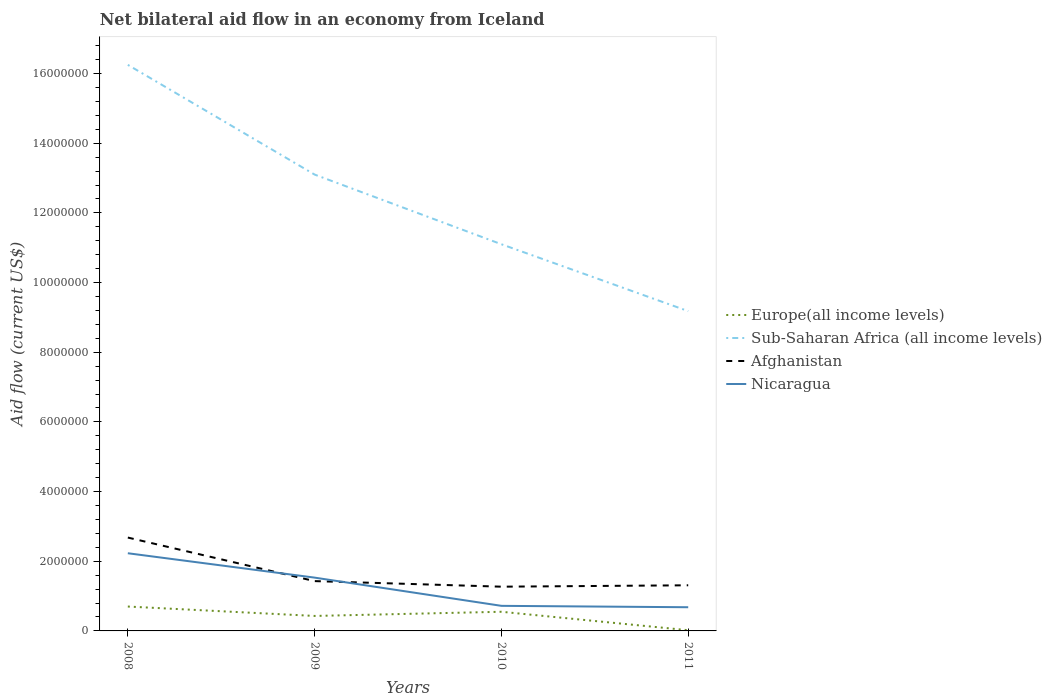Across all years, what is the maximum net bilateral aid flow in Afghanistan?
Your answer should be compact. 1.27e+06. What is the total net bilateral aid flow in Sub-Saharan Africa (all income levels) in the graph?
Provide a short and direct response. 7.07e+06. What is the difference between the highest and the second highest net bilateral aid flow in Afghanistan?
Your response must be concise. 1.41e+06. Are the values on the major ticks of Y-axis written in scientific E-notation?
Offer a terse response. No. Does the graph contain any zero values?
Ensure brevity in your answer.  No. Where does the legend appear in the graph?
Make the answer very short. Center right. How many legend labels are there?
Your answer should be compact. 4. What is the title of the graph?
Offer a terse response. Net bilateral aid flow in an economy from Iceland. What is the Aid flow (current US$) of Sub-Saharan Africa (all income levels) in 2008?
Make the answer very short. 1.62e+07. What is the Aid flow (current US$) in Afghanistan in 2008?
Your answer should be compact. 2.68e+06. What is the Aid flow (current US$) of Nicaragua in 2008?
Provide a succinct answer. 2.23e+06. What is the Aid flow (current US$) in Sub-Saharan Africa (all income levels) in 2009?
Provide a short and direct response. 1.31e+07. What is the Aid flow (current US$) of Afghanistan in 2009?
Your answer should be compact. 1.43e+06. What is the Aid flow (current US$) in Nicaragua in 2009?
Keep it short and to the point. 1.53e+06. What is the Aid flow (current US$) in Sub-Saharan Africa (all income levels) in 2010?
Your response must be concise. 1.11e+07. What is the Aid flow (current US$) in Afghanistan in 2010?
Offer a terse response. 1.27e+06. What is the Aid flow (current US$) of Nicaragua in 2010?
Your answer should be very brief. 7.20e+05. What is the Aid flow (current US$) in Europe(all income levels) in 2011?
Offer a very short reply. 2.00e+04. What is the Aid flow (current US$) in Sub-Saharan Africa (all income levels) in 2011?
Offer a terse response. 9.18e+06. What is the Aid flow (current US$) in Afghanistan in 2011?
Offer a terse response. 1.31e+06. What is the Aid flow (current US$) of Nicaragua in 2011?
Provide a short and direct response. 6.80e+05. Across all years, what is the maximum Aid flow (current US$) in Sub-Saharan Africa (all income levels)?
Give a very brief answer. 1.62e+07. Across all years, what is the maximum Aid flow (current US$) of Afghanistan?
Offer a terse response. 2.68e+06. Across all years, what is the maximum Aid flow (current US$) of Nicaragua?
Your answer should be very brief. 2.23e+06. Across all years, what is the minimum Aid flow (current US$) of Sub-Saharan Africa (all income levels)?
Ensure brevity in your answer.  9.18e+06. Across all years, what is the minimum Aid flow (current US$) of Afghanistan?
Keep it short and to the point. 1.27e+06. Across all years, what is the minimum Aid flow (current US$) of Nicaragua?
Make the answer very short. 6.80e+05. What is the total Aid flow (current US$) of Europe(all income levels) in the graph?
Give a very brief answer. 1.70e+06. What is the total Aid flow (current US$) of Sub-Saharan Africa (all income levels) in the graph?
Keep it short and to the point. 4.96e+07. What is the total Aid flow (current US$) in Afghanistan in the graph?
Your answer should be compact. 6.69e+06. What is the total Aid flow (current US$) in Nicaragua in the graph?
Offer a terse response. 5.16e+06. What is the difference between the Aid flow (current US$) of Europe(all income levels) in 2008 and that in 2009?
Make the answer very short. 2.70e+05. What is the difference between the Aid flow (current US$) in Sub-Saharan Africa (all income levels) in 2008 and that in 2009?
Offer a very short reply. 3.15e+06. What is the difference between the Aid flow (current US$) of Afghanistan in 2008 and that in 2009?
Your response must be concise. 1.25e+06. What is the difference between the Aid flow (current US$) in Nicaragua in 2008 and that in 2009?
Make the answer very short. 7.00e+05. What is the difference between the Aid flow (current US$) in Europe(all income levels) in 2008 and that in 2010?
Give a very brief answer. 1.50e+05. What is the difference between the Aid flow (current US$) of Sub-Saharan Africa (all income levels) in 2008 and that in 2010?
Give a very brief answer. 5.15e+06. What is the difference between the Aid flow (current US$) of Afghanistan in 2008 and that in 2010?
Your answer should be very brief. 1.41e+06. What is the difference between the Aid flow (current US$) in Nicaragua in 2008 and that in 2010?
Your answer should be compact. 1.51e+06. What is the difference between the Aid flow (current US$) of Europe(all income levels) in 2008 and that in 2011?
Your response must be concise. 6.80e+05. What is the difference between the Aid flow (current US$) of Sub-Saharan Africa (all income levels) in 2008 and that in 2011?
Provide a short and direct response. 7.07e+06. What is the difference between the Aid flow (current US$) in Afghanistan in 2008 and that in 2011?
Give a very brief answer. 1.37e+06. What is the difference between the Aid flow (current US$) of Nicaragua in 2008 and that in 2011?
Your answer should be very brief. 1.55e+06. What is the difference between the Aid flow (current US$) of Sub-Saharan Africa (all income levels) in 2009 and that in 2010?
Provide a succinct answer. 2.00e+06. What is the difference between the Aid flow (current US$) in Afghanistan in 2009 and that in 2010?
Your answer should be compact. 1.60e+05. What is the difference between the Aid flow (current US$) in Nicaragua in 2009 and that in 2010?
Your answer should be compact. 8.10e+05. What is the difference between the Aid flow (current US$) in Europe(all income levels) in 2009 and that in 2011?
Keep it short and to the point. 4.10e+05. What is the difference between the Aid flow (current US$) in Sub-Saharan Africa (all income levels) in 2009 and that in 2011?
Your answer should be very brief. 3.92e+06. What is the difference between the Aid flow (current US$) of Nicaragua in 2009 and that in 2011?
Your response must be concise. 8.50e+05. What is the difference between the Aid flow (current US$) of Europe(all income levels) in 2010 and that in 2011?
Make the answer very short. 5.30e+05. What is the difference between the Aid flow (current US$) in Sub-Saharan Africa (all income levels) in 2010 and that in 2011?
Provide a short and direct response. 1.92e+06. What is the difference between the Aid flow (current US$) in Afghanistan in 2010 and that in 2011?
Provide a short and direct response. -4.00e+04. What is the difference between the Aid flow (current US$) of Nicaragua in 2010 and that in 2011?
Keep it short and to the point. 4.00e+04. What is the difference between the Aid flow (current US$) of Europe(all income levels) in 2008 and the Aid flow (current US$) of Sub-Saharan Africa (all income levels) in 2009?
Keep it short and to the point. -1.24e+07. What is the difference between the Aid flow (current US$) in Europe(all income levels) in 2008 and the Aid flow (current US$) in Afghanistan in 2009?
Provide a succinct answer. -7.30e+05. What is the difference between the Aid flow (current US$) of Europe(all income levels) in 2008 and the Aid flow (current US$) of Nicaragua in 2009?
Offer a very short reply. -8.30e+05. What is the difference between the Aid flow (current US$) in Sub-Saharan Africa (all income levels) in 2008 and the Aid flow (current US$) in Afghanistan in 2009?
Ensure brevity in your answer.  1.48e+07. What is the difference between the Aid flow (current US$) in Sub-Saharan Africa (all income levels) in 2008 and the Aid flow (current US$) in Nicaragua in 2009?
Keep it short and to the point. 1.47e+07. What is the difference between the Aid flow (current US$) of Afghanistan in 2008 and the Aid flow (current US$) of Nicaragua in 2009?
Provide a succinct answer. 1.15e+06. What is the difference between the Aid flow (current US$) of Europe(all income levels) in 2008 and the Aid flow (current US$) of Sub-Saharan Africa (all income levels) in 2010?
Ensure brevity in your answer.  -1.04e+07. What is the difference between the Aid flow (current US$) of Europe(all income levels) in 2008 and the Aid flow (current US$) of Afghanistan in 2010?
Your response must be concise. -5.70e+05. What is the difference between the Aid flow (current US$) of Sub-Saharan Africa (all income levels) in 2008 and the Aid flow (current US$) of Afghanistan in 2010?
Offer a very short reply. 1.50e+07. What is the difference between the Aid flow (current US$) of Sub-Saharan Africa (all income levels) in 2008 and the Aid flow (current US$) of Nicaragua in 2010?
Your answer should be compact. 1.55e+07. What is the difference between the Aid flow (current US$) of Afghanistan in 2008 and the Aid flow (current US$) of Nicaragua in 2010?
Offer a terse response. 1.96e+06. What is the difference between the Aid flow (current US$) in Europe(all income levels) in 2008 and the Aid flow (current US$) in Sub-Saharan Africa (all income levels) in 2011?
Offer a terse response. -8.48e+06. What is the difference between the Aid flow (current US$) of Europe(all income levels) in 2008 and the Aid flow (current US$) of Afghanistan in 2011?
Make the answer very short. -6.10e+05. What is the difference between the Aid flow (current US$) of Europe(all income levels) in 2008 and the Aid flow (current US$) of Nicaragua in 2011?
Your response must be concise. 2.00e+04. What is the difference between the Aid flow (current US$) in Sub-Saharan Africa (all income levels) in 2008 and the Aid flow (current US$) in Afghanistan in 2011?
Provide a succinct answer. 1.49e+07. What is the difference between the Aid flow (current US$) in Sub-Saharan Africa (all income levels) in 2008 and the Aid flow (current US$) in Nicaragua in 2011?
Give a very brief answer. 1.56e+07. What is the difference between the Aid flow (current US$) of Europe(all income levels) in 2009 and the Aid flow (current US$) of Sub-Saharan Africa (all income levels) in 2010?
Provide a succinct answer. -1.07e+07. What is the difference between the Aid flow (current US$) in Europe(all income levels) in 2009 and the Aid flow (current US$) in Afghanistan in 2010?
Offer a terse response. -8.40e+05. What is the difference between the Aid flow (current US$) of Sub-Saharan Africa (all income levels) in 2009 and the Aid flow (current US$) of Afghanistan in 2010?
Ensure brevity in your answer.  1.18e+07. What is the difference between the Aid flow (current US$) of Sub-Saharan Africa (all income levels) in 2009 and the Aid flow (current US$) of Nicaragua in 2010?
Offer a terse response. 1.24e+07. What is the difference between the Aid flow (current US$) of Afghanistan in 2009 and the Aid flow (current US$) of Nicaragua in 2010?
Provide a succinct answer. 7.10e+05. What is the difference between the Aid flow (current US$) in Europe(all income levels) in 2009 and the Aid flow (current US$) in Sub-Saharan Africa (all income levels) in 2011?
Offer a very short reply. -8.75e+06. What is the difference between the Aid flow (current US$) of Europe(all income levels) in 2009 and the Aid flow (current US$) of Afghanistan in 2011?
Offer a very short reply. -8.80e+05. What is the difference between the Aid flow (current US$) in Europe(all income levels) in 2009 and the Aid flow (current US$) in Nicaragua in 2011?
Make the answer very short. -2.50e+05. What is the difference between the Aid flow (current US$) of Sub-Saharan Africa (all income levels) in 2009 and the Aid flow (current US$) of Afghanistan in 2011?
Offer a terse response. 1.18e+07. What is the difference between the Aid flow (current US$) in Sub-Saharan Africa (all income levels) in 2009 and the Aid flow (current US$) in Nicaragua in 2011?
Offer a terse response. 1.24e+07. What is the difference between the Aid flow (current US$) of Afghanistan in 2009 and the Aid flow (current US$) of Nicaragua in 2011?
Keep it short and to the point. 7.50e+05. What is the difference between the Aid flow (current US$) of Europe(all income levels) in 2010 and the Aid flow (current US$) of Sub-Saharan Africa (all income levels) in 2011?
Give a very brief answer. -8.63e+06. What is the difference between the Aid flow (current US$) of Europe(all income levels) in 2010 and the Aid flow (current US$) of Afghanistan in 2011?
Your response must be concise. -7.60e+05. What is the difference between the Aid flow (current US$) of Europe(all income levels) in 2010 and the Aid flow (current US$) of Nicaragua in 2011?
Your answer should be very brief. -1.30e+05. What is the difference between the Aid flow (current US$) in Sub-Saharan Africa (all income levels) in 2010 and the Aid flow (current US$) in Afghanistan in 2011?
Keep it short and to the point. 9.79e+06. What is the difference between the Aid flow (current US$) in Sub-Saharan Africa (all income levels) in 2010 and the Aid flow (current US$) in Nicaragua in 2011?
Make the answer very short. 1.04e+07. What is the difference between the Aid flow (current US$) in Afghanistan in 2010 and the Aid flow (current US$) in Nicaragua in 2011?
Give a very brief answer. 5.90e+05. What is the average Aid flow (current US$) in Europe(all income levels) per year?
Make the answer very short. 4.25e+05. What is the average Aid flow (current US$) in Sub-Saharan Africa (all income levels) per year?
Your answer should be very brief. 1.24e+07. What is the average Aid flow (current US$) of Afghanistan per year?
Give a very brief answer. 1.67e+06. What is the average Aid flow (current US$) in Nicaragua per year?
Ensure brevity in your answer.  1.29e+06. In the year 2008, what is the difference between the Aid flow (current US$) of Europe(all income levels) and Aid flow (current US$) of Sub-Saharan Africa (all income levels)?
Give a very brief answer. -1.56e+07. In the year 2008, what is the difference between the Aid flow (current US$) in Europe(all income levels) and Aid flow (current US$) in Afghanistan?
Your response must be concise. -1.98e+06. In the year 2008, what is the difference between the Aid flow (current US$) of Europe(all income levels) and Aid flow (current US$) of Nicaragua?
Offer a very short reply. -1.53e+06. In the year 2008, what is the difference between the Aid flow (current US$) of Sub-Saharan Africa (all income levels) and Aid flow (current US$) of Afghanistan?
Provide a short and direct response. 1.36e+07. In the year 2008, what is the difference between the Aid flow (current US$) in Sub-Saharan Africa (all income levels) and Aid flow (current US$) in Nicaragua?
Offer a terse response. 1.40e+07. In the year 2008, what is the difference between the Aid flow (current US$) in Afghanistan and Aid flow (current US$) in Nicaragua?
Give a very brief answer. 4.50e+05. In the year 2009, what is the difference between the Aid flow (current US$) in Europe(all income levels) and Aid flow (current US$) in Sub-Saharan Africa (all income levels)?
Provide a short and direct response. -1.27e+07. In the year 2009, what is the difference between the Aid flow (current US$) in Europe(all income levels) and Aid flow (current US$) in Nicaragua?
Your response must be concise. -1.10e+06. In the year 2009, what is the difference between the Aid flow (current US$) in Sub-Saharan Africa (all income levels) and Aid flow (current US$) in Afghanistan?
Your response must be concise. 1.17e+07. In the year 2009, what is the difference between the Aid flow (current US$) of Sub-Saharan Africa (all income levels) and Aid flow (current US$) of Nicaragua?
Keep it short and to the point. 1.16e+07. In the year 2009, what is the difference between the Aid flow (current US$) of Afghanistan and Aid flow (current US$) of Nicaragua?
Ensure brevity in your answer.  -1.00e+05. In the year 2010, what is the difference between the Aid flow (current US$) in Europe(all income levels) and Aid flow (current US$) in Sub-Saharan Africa (all income levels)?
Give a very brief answer. -1.06e+07. In the year 2010, what is the difference between the Aid flow (current US$) in Europe(all income levels) and Aid flow (current US$) in Afghanistan?
Ensure brevity in your answer.  -7.20e+05. In the year 2010, what is the difference between the Aid flow (current US$) in Europe(all income levels) and Aid flow (current US$) in Nicaragua?
Ensure brevity in your answer.  -1.70e+05. In the year 2010, what is the difference between the Aid flow (current US$) of Sub-Saharan Africa (all income levels) and Aid flow (current US$) of Afghanistan?
Keep it short and to the point. 9.83e+06. In the year 2010, what is the difference between the Aid flow (current US$) in Sub-Saharan Africa (all income levels) and Aid flow (current US$) in Nicaragua?
Ensure brevity in your answer.  1.04e+07. In the year 2011, what is the difference between the Aid flow (current US$) in Europe(all income levels) and Aid flow (current US$) in Sub-Saharan Africa (all income levels)?
Provide a short and direct response. -9.16e+06. In the year 2011, what is the difference between the Aid flow (current US$) in Europe(all income levels) and Aid flow (current US$) in Afghanistan?
Make the answer very short. -1.29e+06. In the year 2011, what is the difference between the Aid flow (current US$) of Europe(all income levels) and Aid flow (current US$) of Nicaragua?
Keep it short and to the point. -6.60e+05. In the year 2011, what is the difference between the Aid flow (current US$) in Sub-Saharan Africa (all income levels) and Aid flow (current US$) in Afghanistan?
Provide a short and direct response. 7.87e+06. In the year 2011, what is the difference between the Aid flow (current US$) in Sub-Saharan Africa (all income levels) and Aid flow (current US$) in Nicaragua?
Give a very brief answer. 8.50e+06. In the year 2011, what is the difference between the Aid flow (current US$) in Afghanistan and Aid flow (current US$) in Nicaragua?
Offer a very short reply. 6.30e+05. What is the ratio of the Aid flow (current US$) in Europe(all income levels) in 2008 to that in 2009?
Provide a succinct answer. 1.63. What is the ratio of the Aid flow (current US$) in Sub-Saharan Africa (all income levels) in 2008 to that in 2009?
Give a very brief answer. 1.24. What is the ratio of the Aid flow (current US$) in Afghanistan in 2008 to that in 2009?
Make the answer very short. 1.87. What is the ratio of the Aid flow (current US$) in Nicaragua in 2008 to that in 2009?
Offer a very short reply. 1.46. What is the ratio of the Aid flow (current US$) of Europe(all income levels) in 2008 to that in 2010?
Offer a terse response. 1.27. What is the ratio of the Aid flow (current US$) in Sub-Saharan Africa (all income levels) in 2008 to that in 2010?
Offer a terse response. 1.46. What is the ratio of the Aid flow (current US$) in Afghanistan in 2008 to that in 2010?
Give a very brief answer. 2.11. What is the ratio of the Aid flow (current US$) in Nicaragua in 2008 to that in 2010?
Ensure brevity in your answer.  3.1. What is the ratio of the Aid flow (current US$) of Europe(all income levels) in 2008 to that in 2011?
Make the answer very short. 35. What is the ratio of the Aid flow (current US$) in Sub-Saharan Africa (all income levels) in 2008 to that in 2011?
Provide a short and direct response. 1.77. What is the ratio of the Aid flow (current US$) in Afghanistan in 2008 to that in 2011?
Keep it short and to the point. 2.05. What is the ratio of the Aid flow (current US$) in Nicaragua in 2008 to that in 2011?
Offer a terse response. 3.28. What is the ratio of the Aid flow (current US$) of Europe(all income levels) in 2009 to that in 2010?
Your answer should be compact. 0.78. What is the ratio of the Aid flow (current US$) of Sub-Saharan Africa (all income levels) in 2009 to that in 2010?
Give a very brief answer. 1.18. What is the ratio of the Aid flow (current US$) of Afghanistan in 2009 to that in 2010?
Offer a terse response. 1.13. What is the ratio of the Aid flow (current US$) in Nicaragua in 2009 to that in 2010?
Offer a terse response. 2.12. What is the ratio of the Aid flow (current US$) in Sub-Saharan Africa (all income levels) in 2009 to that in 2011?
Your answer should be compact. 1.43. What is the ratio of the Aid flow (current US$) in Afghanistan in 2009 to that in 2011?
Give a very brief answer. 1.09. What is the ratio of the Aid flow (current US$) of Nicaragua in 2009 to that in 2011?
Offer a terse response. 2.25. What is the ratio of the Aid flow (current US$) in Europe(all income levels) in 2010 to that in 2011?
Keep it short and to the point. 27.5. What is the ratio of the Aid flow (current US$) of Sub-Saharan Africa (all income levels) in 2010 to that in 2011?
Your response must be concise. 1.21. What is the ratio of the Aid flow (current US$) of Afghanistan in 2010 to that in 2011?
Offer a very short reply. 0.97. What is the ratio of the Aid flow (current US$) of Nicaragua in 2010 to that in 2011?
Make the answer very short. 1.06. What is the difference between the highest and the second highest Aid flow (current US$) in Europe(all income levels)?
Give a very brief answer. 1.50e+05. What is the difference between the highest and the second highest Aid flow (current US$) of Sub-Saharan Africa (all income levels)?
Make the answer very short. 3.15e+06. What is the difference between the highest and the second highest Aid flow (current US$) of Afghanistan?
Make the answer very short. 1.25e+06. What is the difference between the highest and the lowest Aid flow (current US$) of Europe(all income levels)?
Make the answer very short. 6.80e+05. What is the difference between the highest and the lowest Aid flow (current US$) in Sub-Saharan Africa (all income levels)?
Provide a short and direct response. 7.07e+06. What is the difference between the highest and the lowest Aid flow (current US$) in Afghanistan?
Offer a very short reply. 1.41e+06. What is the difference between the highest and the lowest Aid flow (current US$) in Nicaragua?
Your answer should be compact. 1.55e+06. 